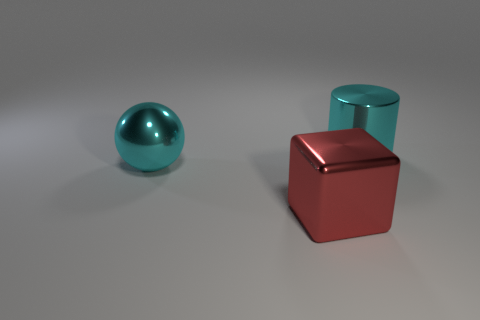Add 2 large cyan things. How many objects exist? 5 Add 3 cyan cylinders. How many cyan cylinders are left? 4 Add 2 brown matte blocks. How many brown matte blocks exist? 2 Subtract 0 green blocks. How many objects are left? 3 Subtract all cylinders. How many objects are left? 2 Subtract all metal cylinders. Subtract all big shiny spheres. How many objects are left? 1 